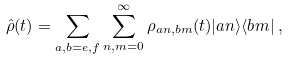Convert formula to latex. <formula><loc_0><loc_0><loc_500><loc_500>\hat { \rho } ( t ) = \sum _ { a , b = e , f } \sum _ { n , m = 0 } ^ { \infty } \rho _ { a n , b m } ( t ) | a n \rangle \langle b m | \, ,</formula> 